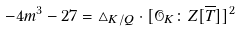Convert formula to latex. <formula><loc_0><loc_0><loc_500><loc_500>- 4 m ^ { 3 } - 2 7 = \triangle _ { K / Q } \cdot [ \mathcal { O } _ { K } \colon Z [ \overline { T } ] ] ^ { 2 }</formula> 